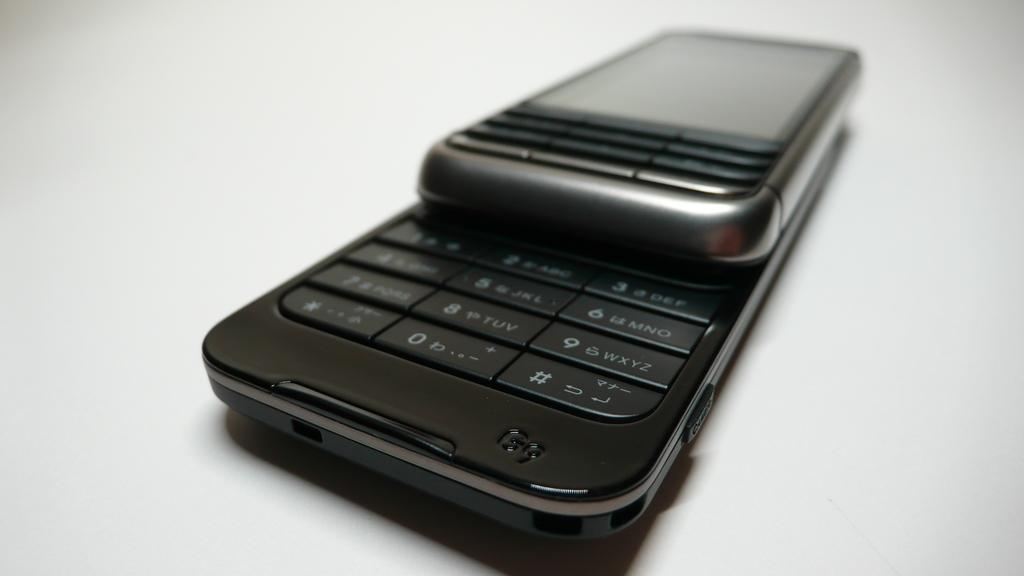<image>
Describe the image concisely. An older  G9 slide style phone lays open on a surface. 